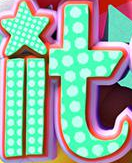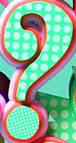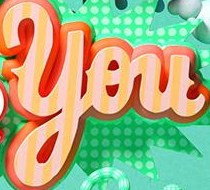What text is displayed in these images sequentially, separated by a semicolon? it; ?; You 